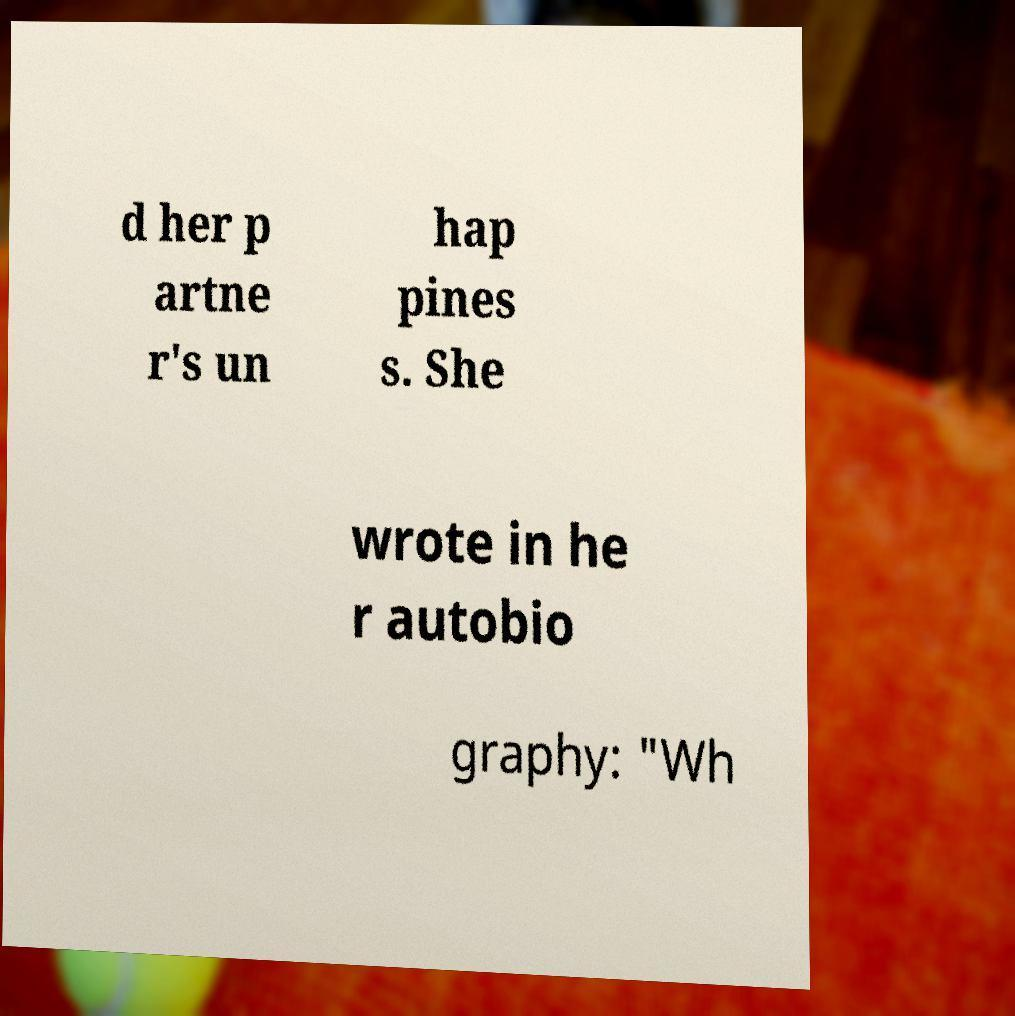Can you accurately transcribe the text from the provided image for me? d her p artne r's un hap pines s. She wrote in he r autobio graphy: "Wh 